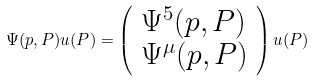Convert formula to latex. <formula><loc_0><loc_0><loc_500><loc_500>\Psi ( p , P ) u ( P ) = \left ( \begin{array} { l } { { \Psi ^ { 5 } ( p , P ) } } \\ { { \Psi ^ { \mu } ( p , P ) } } \end{array} \right ) u ( P )</formula> 